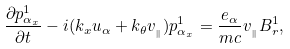Convert formula to latex. <formula><loc_0><loc_0><loc_500><loc_500>\frac { \partial p ^ { 1 } _ { { \alpha } _ { x } } } { \partial t } - i ( k _ { x } u _ { \alpha } + k _ { \theta } v _ { _ { \| } } ) p ^ { 1 } _ { { \alpha } _ { x } } = \frac { e _ { \alpha } } { m c } v _ { _ { \| } } B ^ { 1 } _ { r } ,</formula> 